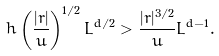<formula> <loc_0><loc_0><loc_500><loc_500>h \left ( \frac { | r | } { u } \right ) ^ { 1 / 2 } L ^ { d / 2 } > \frac { | r | ^ { 3 / 2 } } { u } L ^ { d - 1 } .</formula> 